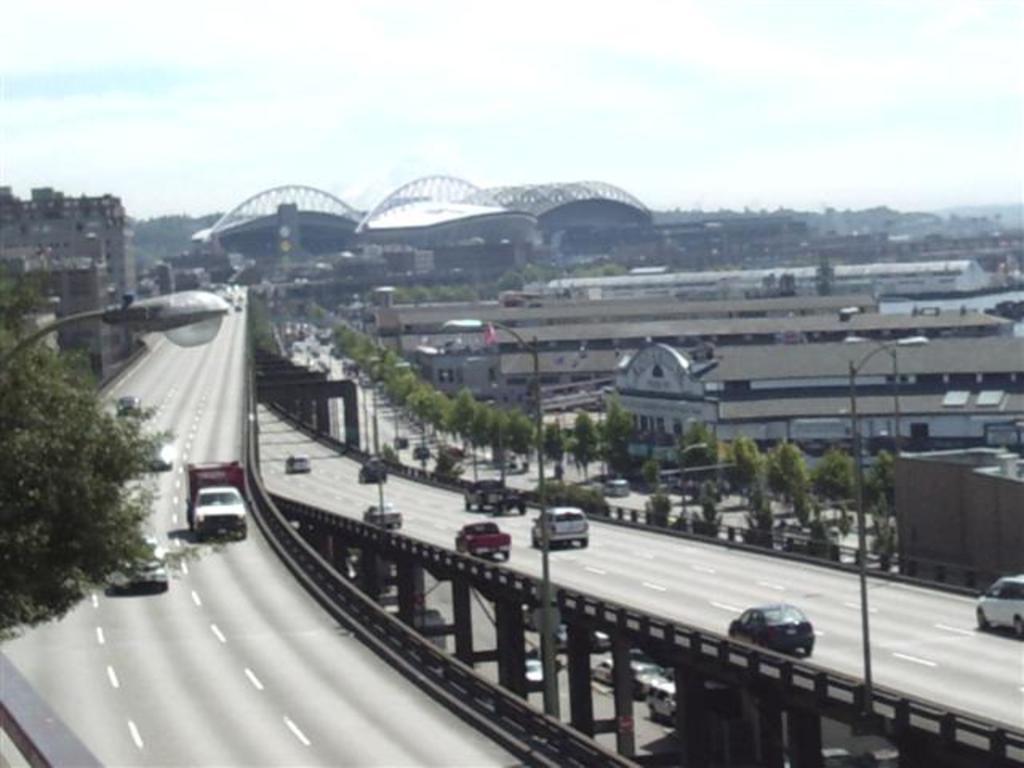Could you give a brief overview of what you see in this image? In this image we can see a group of cars parked on the road on a bridge. To the right side of the image we can see a tree, light pole. In the background, we can see a group of trees, buildings, bridge and the sky. 